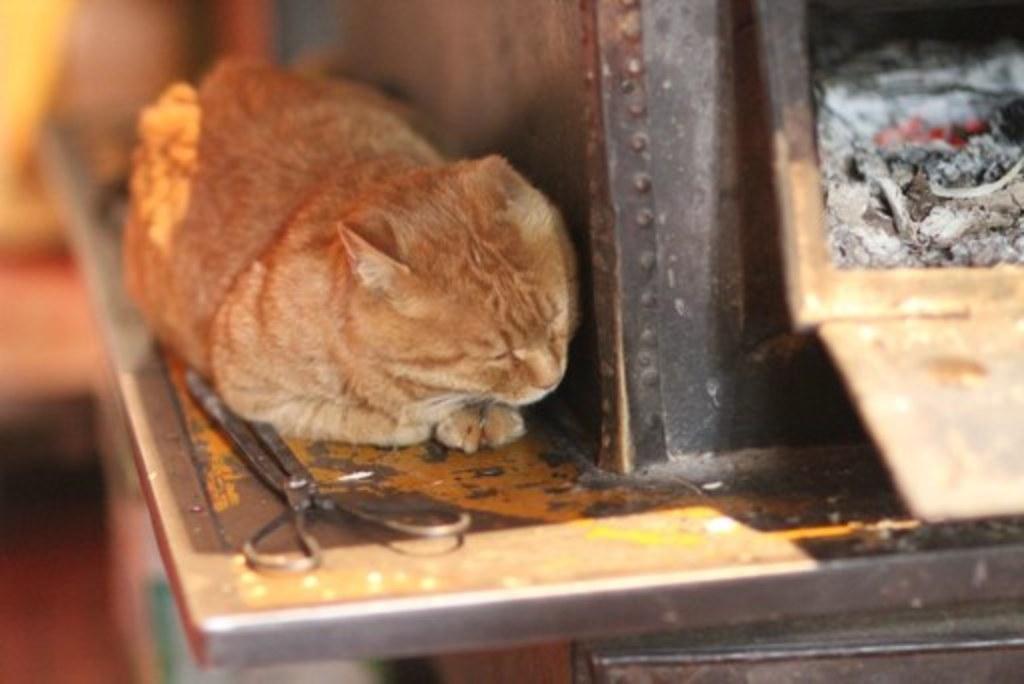How would you summarize this image in a sentence or two? In this image I see a cat over here which is of cream and brown in color and I see a scissor over here and I see the ash which is of white and black in color and I see that it is blurred in the background. 